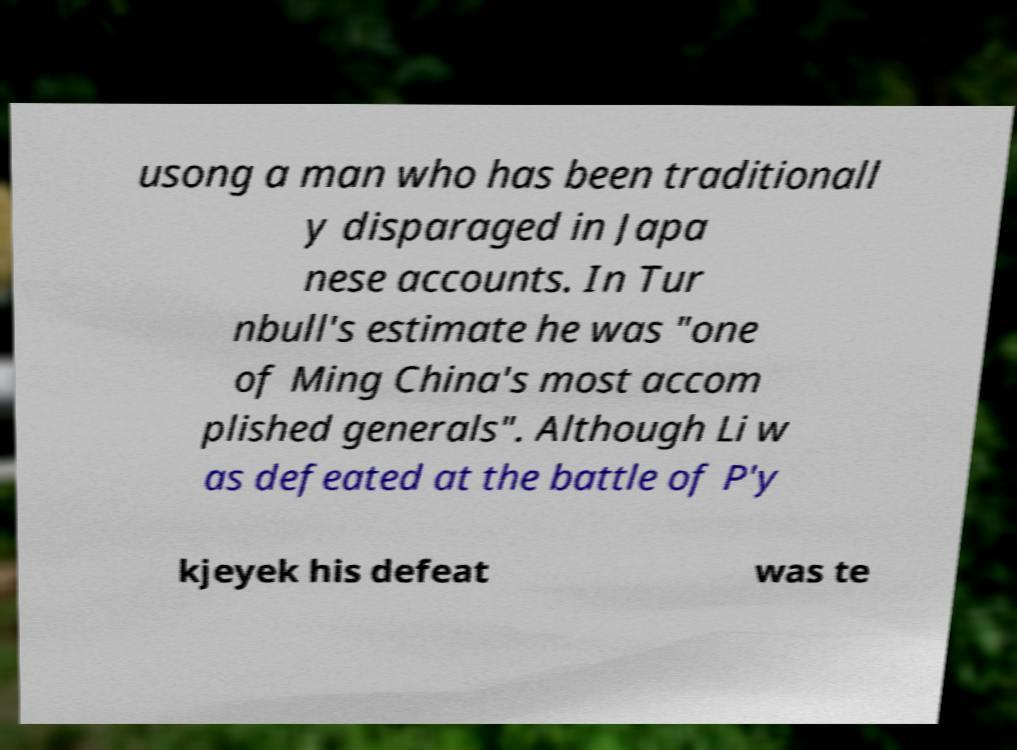Can you read and provide the text displayed in the image?This photo seems to have some interesting text. Can you extract and type it out for me? usong a man who has been traditionall y disparaged in Japa nese accounts. In Tur nbull's estimate he was "one of Ming China's most accom plished generals". Although Li w as defeated at the battle of P'y kjeyek his defeat was te 